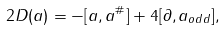<formula> <loc_0><loc_0><loc_500><loc_500>2 D ( a ) = - [ a , a ^ { \# } ] + 4 [ \partial , a _ { o d d } ] ,</formula> 